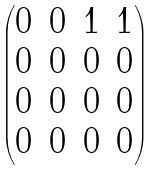Convert formula to latex. <formula><loc_0><loc_0><loc_500><loc_500>\begin{pmatrix} 0 & 0 & 1 & 1 \\ 0 & 0 & 0 & 0 \\ 0 & 0 & 0 & 0 \\ 0 & 0 & 0 & 0 \end{pmatrix}</formula> 